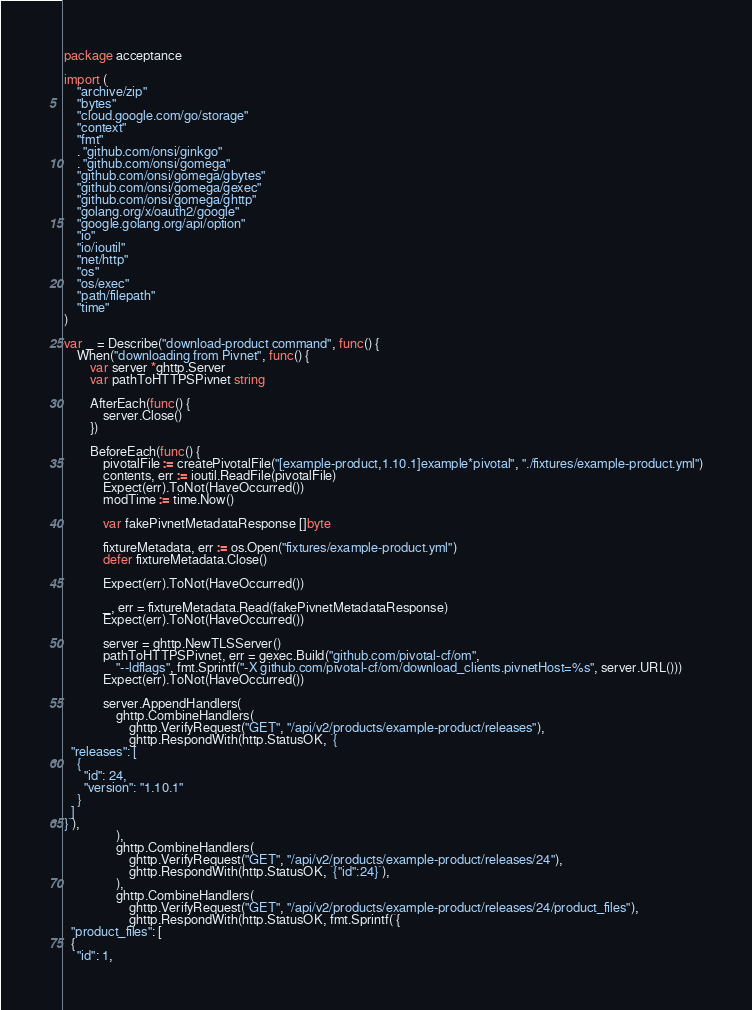Convert code to text. <code><loc_0><loc_0><loc_500><loc_500><_Go_>package acceptance

import (
	"archive/zip"
	"bytes"
	"cloud.google.com/go/storage"
	"context"
	"fmt"
	. "github.com/onsi/ginkgo"
	. "github.com/onsi/gomega"
	"github.com/onsi/gomega/gbytes"
	"github.com/onsi/gomega/gexec"
	"github.com/onsi/gomega/ghttp"
	"golang.org/x/oauth2/google"
	"google.golang.org/api/option"
	"io"
	"io/ioutil"
	"net/http"
	"os"
	"os/exec"
	"path/filepath"
	"time"
)

var _ = Describe("download-product command", func() {
	When("downloading from Pivnet", func() {
		var server *ghttp.Server
		var pathToHTTPSPivnet string

		AfterEach(func() {
			server.Close()
		})

		BeforeEach(func() {
			pivotalFile := createPivotalFile("[example-product,1.10.1]example*pivotal", "./fixtures/example-product.yml")
			contents, err := ioutil.ReadFile(pivotalFile)
			Expect(err).ToNot(HaveOccurred())
			modTime := time.Now()

			var fakePivnetMetadataResponse []byte

			fixtureMetadata, err := os.Open("fixtures/example-product.yml")
			defer fixtureMetadata.Close()

			Expect(err).ToNot(HaveOccurred())

			_, err = fixtureMetadata.Read(fakePivnetMetadataResponse)
			Expect(err).ToNot(HaveOccurred())

			server = ghttp.NewTLSServer()
			pathToHTTPSPivnet, err = gexec.Build("github.com/pivotal-cf/om",
				"--ldflags", fmt.Sprintf("-X github.com/pivotal-cf/om/download_clients.pivnetHost=%s", server.URL()))
			Expect(err).ToNot(HaveOccurred())

			server.AppendHandlers(
				ghttp.CombineHandlers(
					ghttp.VerifyRequest("GET", "/api/v2/products/example-product/releases"),
					ghttp.RespondWith(http.StatusOK, `{
  "releases": [
    {
      "id": 24,
      "version": "1.10.1"
    }
  ]
}`),
				),
				ghttp.CombineHandlers(
					ghttp.VerifyRequest("GET", "/api/v2/products/example-product/releases/24"),
					ghttp.RespondWith(http.StatusOK, `{"id":24}`),
				),
				ghttp.CombineHandlers(
					ghttp.VerifyRequest("GET", "/api/v2/products/example-product/releases/24/product_files"),
					ghttp.RespondWith(http.StatusOK, fmt.Sprintf(`{
  "product_files": [
  {
    "id": 1,</code> 